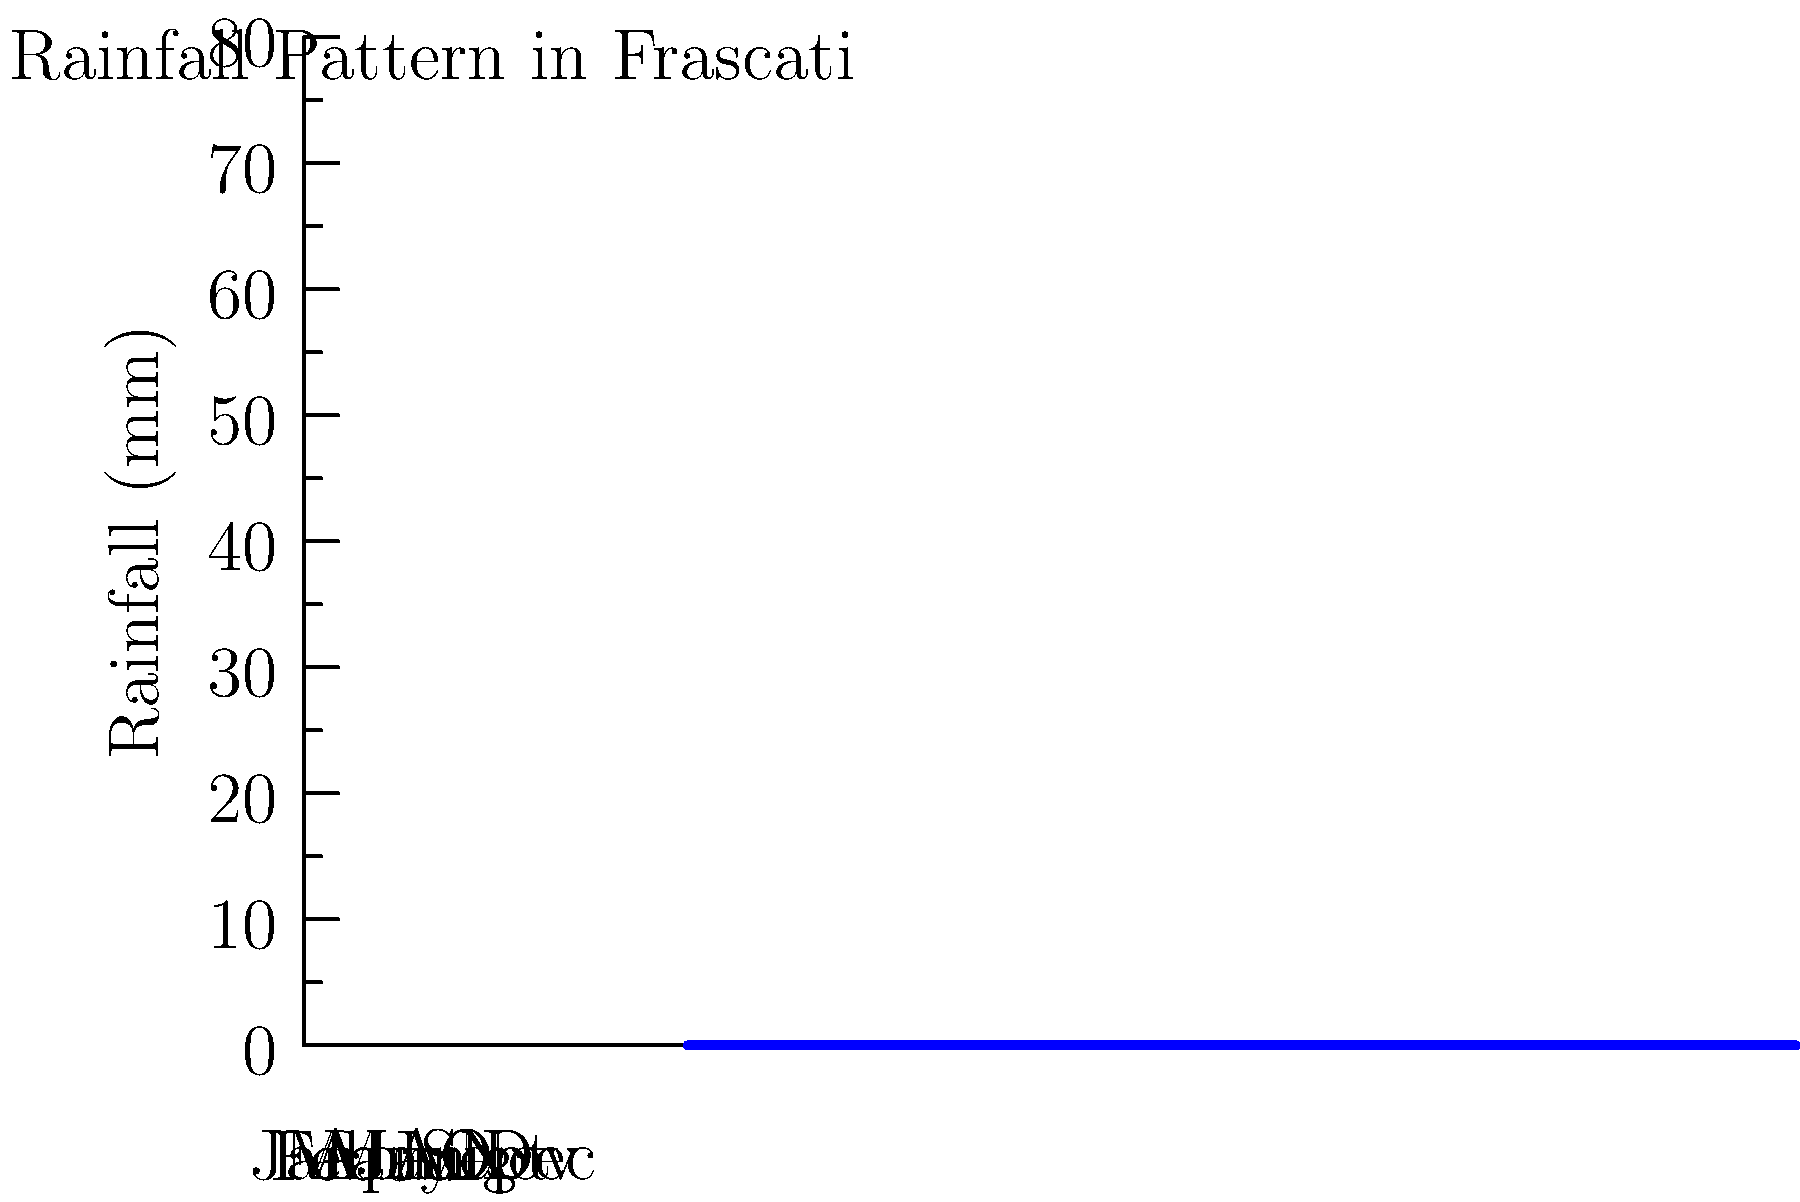Based on the rainfall pattern shown in the graph for Frascati, during which month would your vineyard likely require the most irrigation? Assuming vines need at least 50mm of water per month, calculate the additional water needed for irrigation in that month. To answer this question, we need to follow these steps:

1. Identify the month with the lowest rainfall:
   From the graph, we can see that July has the lowest rainfall at approximately 18mm.

2. Calculate the water deficit:
   Vines need at least 50mm of water per month.
   Water deficit = Required water - Actual rainfall
   $$\text{Water deficit} = 50\text{mm} - 18\text{mm} = 32\text{mm}$$

3. Confirm that July needs the most irrigation:
   We should quickly check other months to ensure no other month has a larger deficit.
   June and August also have low rainfall, but both are higher than July.

Therefore, July would require the most irrigation, and the additional water needed for irrigation in that month is 32mm.
Answer: July; 32mm 